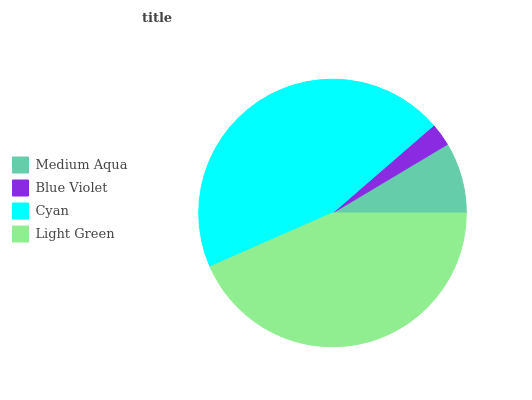Is Blue Violet the minimum?
Answer yes or no. Yes. Is Cyan the maximum?
Answer yes or no. Yes. Is Cyan the minimum?
Answer yes or no. No. Is Blue Violet the maximum?
Answer yes or no. No. Is Cyan greater than Blue Violet?
Answer yes or no. Yes. Is Blue Violet less than Cyan?
Answer yes or no. Yes. Is Blue Violet greater than Cyan?
Answer yes or no. No. Is Cyan less than Blue Violet?
Answer yes or no. No. Is Light Green the high median?
Answer yes or no. Yes. Is Medium Aqua the low median?
Answer yes or no. Yes. Is Cyan the high median?
Answer yes or no. No. Is Blue Violet the low median?
Answer yes or no. No. 